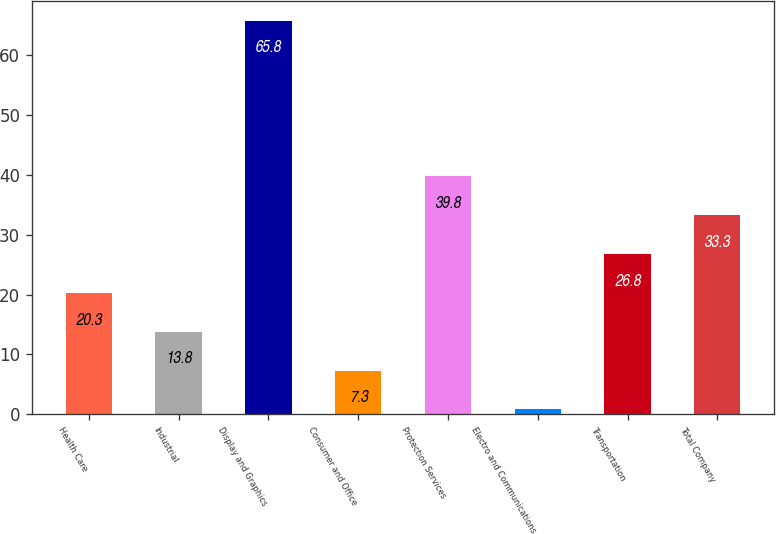Convert chart to OTSL. <chart><loc_0><loc_0><loc_500><loc_500><bar_chart><fcel>Health Care<fcel>Industrial<fcel>Display and Graphics<fcel>Consumer and Office<fcel>Protection Services<fcel>Electro and Communications<fcel>Transportation<fcel>Total Company<nl><fcel>20.3<fcel>13.8<fcel>65.8<fcel>7.3<fcel>39.8<fcel>0.8<fcel>26.8<fcel>33.3<nl></chart> 